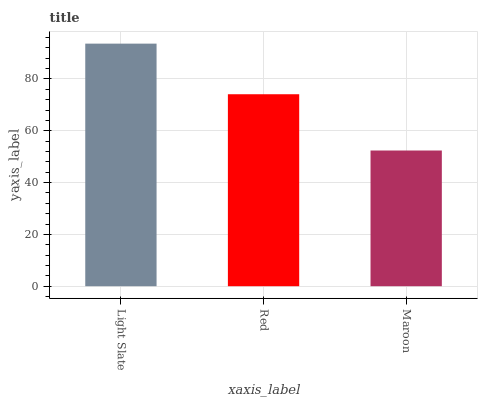Is Maroon the minimum?
Answer yes or no. Yes. Is Light Slate the maximum?
Answer yes or no. Yes. Is Red the minimum?
Answer yes or no. No. Is Red the maximum?
Answer yes or no. No. Is Light Slate greater than Red?
Answer yes or no. Yes. Is Red less than Light Slate?
Answer yes or no. Yes. Is Red greater than Light Slate?
Answer yes or no. No. Is Light Slate less than Red?
Answer yes or no. No. Is Red the high median?
Answer yes or no. Yes. Is Red the low median?
Answer yes or no. Yes. Is Light Slate the high median?
Answer yes or no. No. Is Light Slate the low median?
Answer yes or no. No. 